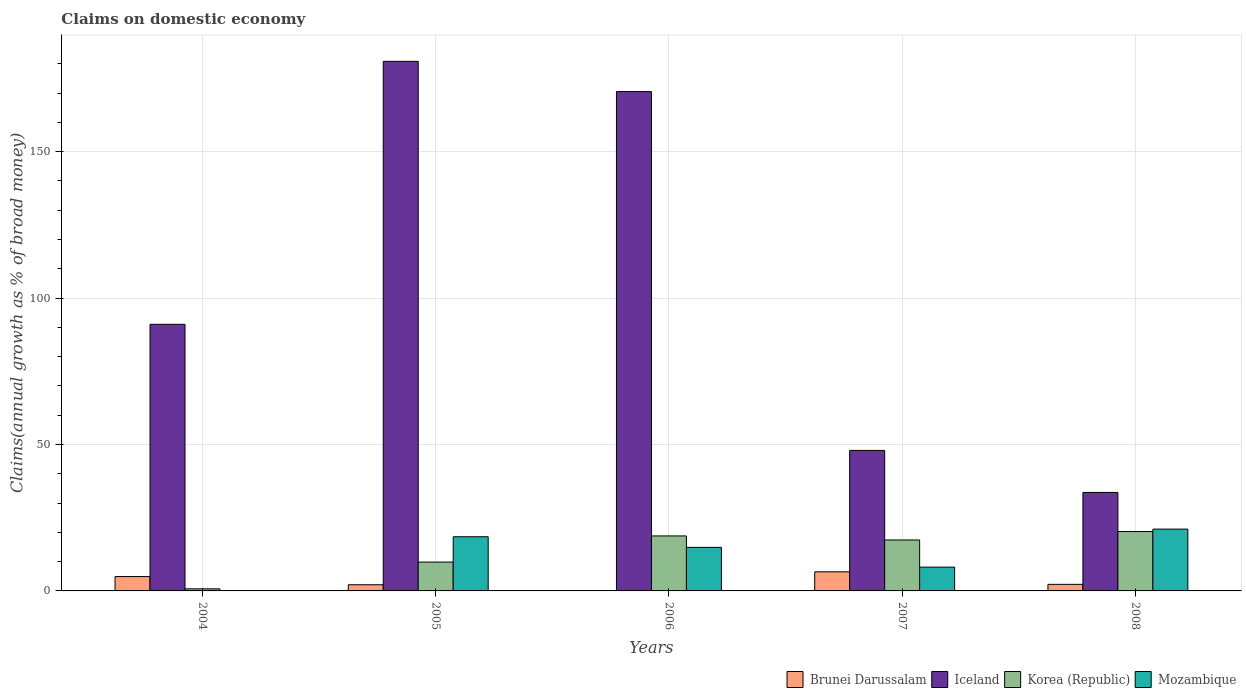How many groups of bars are there?
Your answer should be compact. 5. Are the number of bars per tick equal to the number of legend labels?
Offer a terse response. No. In how many cases, is the number of bars for a given year not equal to the number of legend labels?
Your answer should be compact. 2. What is the percentage of broad money claimed on domestic economy in Korea (Republic) in 2006?
Make the answer very short. 18.78. Across all years, what is the maximum percentage of broad money claimed on domestic economy in Mozambique?
Your answer should be very brief. 21.11. Across all years, what is the minimum percentage of broad money claimed on domestic economy in Iceland?
Keep it short and to the point. 33.63. What is the total percentage of broad money claimed on domestic economy in Korea (Republic) in the graph?
Offer a very short reply. 67.02. What is the difference between the percentage of broad money claimed on domestic economy in Korea (Republic) in 2005 and that in 2006?
Provide a short and direct response. -8.93. What is the difference between the percentage of broad money claimed on domestic economy in Mozambique in 2005 and the percentage of broad money claimed on domestic economy in Brunei Darussalam in 2006?
Keep it short and to the point. 18.5. What is the average percentage of broad money claimed on domestic economy in Korea (Republic) per year?
Make the answer very short. 13.4. In the year 2005, what is the difference between the percentage of broad money claimed on domestic economy in Korea (Republic) and percentage of broad money claimed on domestic economy in Mozambique?
Make the answer very short. -8.65. What is the ratio of the percentage of broad money claimed on domestic economy in Iceland in 2004 to that in 2007?
Provide a short and direct response. 1.9. Is the percentage of broad money claimed on domestic economy in Mozambique in 2006 less than that in 2008?
Provide a succinct answer. Yes. What is the difference between the highest and the second highest percentage of broad money claimed on domestic economy in Brunei Darussalam?
Ensure brevity in your answer.  1.62. What is the difference between the highest and the lowest percentage of broad money claimed on domestic economy in Korea (Republic)?
Keep it short and to the point. 19.55. In how many years, is the percentage of broad money claimed on domestic economy in Mozambique greater than the average percentage of broad money claimed on domestic economy in Mozambique taken over all years?
Give a very brief answer. 3. Is it the case that in every year, the sum of the percentage of broad money claimed on domestic economy in Brunei Darussalam and percentage of broad money claimed on domestic economy in Mozambique is greater than the percentage of broad money claimed on domestic economy in Iceland?
Provide a short and direct response. No. How many bars are there?
Your answer should be very brief. 18. Are all the bars in the graph horizontal?
Provide a short and direct response. No. What is the difference between two consecutive major ticks on the Y-axis?
Provide a succinct answer. 50. Are the values on the major ticks of Y-axis written in scientific E-notation?
Your answer should be compact. No. Does the graph contain grids?
Offer a very short reply. Yes. How many legend labels are there?
Offer a very short reply. 4. What is the title of the graph?
Provide a short and direct response. Claims on domestic economy. Does "Bermuda" appear as one of the legend labels in the graph?
Your answer should be compact. No. What is the label or title of the X-axis?
Keep it short and to the point. Years. What is the label or title of the Y-axis?
Provide a short and direct response. Claims(annual growth as % of broad money). What is the Claims(annual growth as % of broad money) in Brunei Darussalam in 2004?
Your answer should be compact. 4.9. What is the Claims(annual growth as % of broad money) of Iceland in 2004?
Keep it short and to the point. 91.04. What is the Claims(annual growth as % of broad money) in Korea (Republic) in 2004?
Your answer should be compact. 0.72. What is the Claims(annual growth as % of broad money) in Mozambique in 2004?
Your answer should be compact. 0. What is the Claims(annual growth as % of broad money) in Brunei Darussalam in 2005?
Ensure brevity in your answer.  2.11. What is the Claims(annual growth as % of broad money) of Iceland in 2005?
Offer a very short reply. 180.84. What is the Claims(annual growth as % of broad money) in Korea (Republic) in 2005?
Offer a very short reply. 9.85. What is the Claims(annual growth as % of broad money) of Mozambique in 2005?
Offer a very short reply. 18.5. What is the Claims(annual growth as % of broad money) in Brunei Darussalam in 2006?
Your answer should be compact. 0. What is the Claims(annual growth as % of broad money) in Iceland in 2006?
Give a very brief answer. 170.52. What is the Claims(annual growth as % of broad money) in Korea (Republic) in 2006?
Give a very brief answer. 18.78. What is the Claims(annual growth as % of broad money) of Mozambique in 2006?
Your response must be concise. 14.87. What is the Claims(annual growth as % of broad money) of Brunei Darussalam in 2007?
Provide a short and direct response. 6.52. What is the Claims(annual growth as % of broad money) of Iceland in 2007?
Offer a terse response. 47.98. What is the Claims(annual growth as % of broad money) in Korea (Republic) in 2007?
Ensure brevity in your answer.  17.4. What is the Claims(annual growth as % of broad money) in Mozambique in 2007?
Make the answer very short. 8.13. What is the Claims(annual growth as % of broad money) in Brunei Darussalam in 2008?
Give a very brief answer. 2.24. What is the Claims(annual growth as % of broad money) of Iceland in 2008?
Your answer should be compact. 33.63. What is the Claims(annual growth as % of broad money) of Korea (Republic) in 2008?
Your response must be concise. 20.27. What is the Claims(annual growth as % of broad money) in Mozambique in 2008?
Your answer should be compact. 21.11. Across all years, what is the maximum Claims(annual growth as % of broad money) in Brunei Darussalam?
Make the answer very short. 6.52. Across all years, what is the maximum Claims(annual growth as % of broad money) of Iceland?
Provide a short and direct response. 180.84. Across all years, what is the maximum Claims(annual growth as % of broad money) in Korea (Republic)?
Your answer should be compact. 20.27. Across all years, what is the maximum Claims(annual growth as % of broad money) of Mozambique?
Provide a short and direct response. 21.11. Across all years, what is the minimum Claims(annual growth as % of broad money) of Iceland?
Ensure brevity in your answer.  33.63. Across all years, what is the minimum Claims(annual growth as % of broad money) of Korea (Republic)?
Offer a terse response. 0.72. What is the total Claims(annual growth as % of broad money) of Brunei Darussalam in the graph?
Make the answer very short. 15.77. What is the total Claims(annual growth as % of broad money) of Iceland in the graph?
Keep it short and to the point. 524.01. What is the total Claims(annual growth as % of broad money) in Korea (Republic) in the graph?
Provide a short and direct response. 67.02. What is the total Claims(annual growth as % of broad money) in Mozambique in the graph?
Your answer should be very brief. 62.61. What is the difference between the Claims(annual growth as % of broad money) in Brunei Darussalam in 2004 and that in 2005?
Your answer should be compact. 2.79. What is the difference between the Claims(annual growth as % of broad money) in Iceland in 2004 and that in 2005?
Your response must be concise. -89.79. What is the difference between the Claims(annual growth as % of broad money) in Korea (Republic) in 2004 and that in 2005?
Make the answer very short. -9.13. What is the difference between the Claims(annual growth as % of broad money) in Iceland in 2004 and that in 2006?
Make the answer very short. -79.47. What is the difference between the Claims(annual growth as % of broad money) of Korea (Republic) in 2004 and that in 2006?
Your answer should be very brief. -18.06. What is the difference between the Claims(annual growth as % of broad money) of Brunei Darussalam in 2004 and that in 2007?
Make the answer very short. -1.62. What is the difference between the Claims(annual growth as % of broad money) in Iceland in 2004 and that in 2007?
Provide a short and direct response. 43.06. What is the difference between the Claims(annual growth as % of broad money) of Korea (Republic) in 2004 and that in 2007?
Make the answer very short. -16.68. What is the difference between the Claims(annual growth as % of broad money) of Brunei Darussalam in 2004 and that in 2008?
Ensure brevity in your answer.  2.66. What is the difference between the Claims(annual growth as % of broad money) in Iceland in 2004 and that in 2008?
Your answer should be very brief. 57.41. What is the difference between the Claims(annual growth as % of broad money) of Korea (Republic) in 2004 and that in 2008?
Your answer should be compact. -19.55. What is the difference between the Claims(annual growth as % of broad money) of Iceland in 2005 and that in 2006?
Your answer should be compact. 10.32. What is the difference between the Claims(annual growth as % of broad money) in Korea (Republic) in 2005 and that in 2006?
Make the answer very short. -8.93. What is the difference between the Claims(annual growth as % of broad money) of Mozambique in 2005 and that in 2006?
Your answer should be very brief. 3.62. What is the difference between the Claims(annual growth as % of broad money) of Brunei Darussalam in 2005 and that in 2007?
Offer a very short reply. -4.42. What is the difference between the Claims(annual growth as % of broad money) of Iceland in 2005 and that in 2007?
Provide a succinct answer. 132.86. What is the difference between the Claims(annual growth as % of broad money) in Korea (Republic) in 2005 and that in 2007?
Provide a succinct answer. -7.54. What is the difference between the Claims(annual growth as % of broad money) of Mozambique in 2005 and that in 2007?
Your answer should be compact. 10.37. What is the difference between the Claims(annual growth as % of broad money) of Brunei Darussalam in 2005 and that in 2008?
Ensure brevity in your answer.  -0.14. What is the difference between the Claims(annual growth as % of broad money) of Iceland in 2005 and that in 2008?
Your answer should be very brief. 147.21. What is the difference between the Claims(annual growth as % of broad money) of Korea (Republic) in 2005 and that in 2008?
Provide a short and direct response. -10.42. What is the difference between the Claims(annual growth as % of broad money) in Mozambique in 2005 and that in 2008?
Your answer should be very brief. -2.61. What is the difference between the Claims(annual growth as % of broad money) of Iceland in 2006 and that in 2007?
Keep it short and to the point. 122.54. What is the difference between the Claims(annual growth as % of broad money) in Korea (Republic) in 2006 and that in 2007?
Ensure brevity in your answer.  1.38. What is the difference between the Claims(annual growth as % of broad money) of Mozambique in 2006 and that in 2007?
Provide a short and direct response. 6.75. What is the difference between the Claims(annual growth as % of broad money) in Iceland in 2006 and that in 2008?
Ensure brevity in your answer.  136.89. What is the difference between the Claims(annual growth as % of broad money) of Korea (Republic) in 2006 and that in 2008?
Your response must be concise. -1.49. What is the difference between the Claims(annual growth as % of broad money) of Mozambique in 2006 and that in 2008?
Offer a terse response. -6.24. What is the difference between the Claims(annual growth as % of broad money) of Brunei Darussalam in 2007 and that in 2008?
Provide a succinct answer. 4.28. What is the difference between the Claims(annual growth as % of broad money) of Iceland in 2007 and that in 2008?
Your answer should be very brief. 14.35. What is the difference between the Claims(annual growth as % of broad money) of Korea (Republic) in 2007 and that in 2008?
Your answer should be compact. -2.88. What is the difference between the Claims(annual growth as % of broad money) of Mozambique in 2007 and that in 2008?
Keep it short and to the point. -12.99. What is the difference between the Claims(annual growth as % of broad money) in Brunei Darussalam in 2004 and the Claims(annual growth as % of broad money) in Iceland in 2005?
Offer a very short reply. -175.94. What is the difference between the Claims(annual growth as % of broad money) in Brunei Darussalam in 2004 and the Claims(annual growth as % of broad money) in Korea (Republic) in 2005?
Give a very brief answer. -4.95. What is the difference between the Claims(annual growth as % of broad money) in Brunei Darussalam in 2004 and the Claims(annual growth as % of broad money) in Mozambique in 2005?
Provide a short and direct response. -13.6. What is the difference between the Claims(annual growth as % of broad money) of Iceland in 2004 and the Claims(annual growth as % of broad money) of Korea (Republic) in 2005?
Offer a very short reply. 81.19. What is the difference between the Claims(annual growth as % of broad money) of Iceland in 2004 and the Claims(annual growth as % of broad money) of Mozambique in 2005?
Your answer should be very brief. 72.55. What is the difference between the Claims(annual growth as % of broad money) of Korea (Republic) in 2004 and the Claims(annual growth as % of broad money) of Mozambique in 2005?
Your answer should be compact. -17.78. What is the difference between the Claims(annual growth as % of broad money) of Brunei Darussalam in 2004 and the Claims(annual growth as % of broad money) of Iceland in 2006?
Keep it short and to the point. -165.62. What is the difference between the Claims(annual growth as % of broad money) in Brunei Darussalam in 2004 and the Claims(annual growth as % of broad money) in Korea (Republic) in 2006?
Offer a very short reply. -13.88. What is the difference between the Claims(annual growth as % of broad money) in Brunei Darussalam in 2004 and the Claims(annual growth as % of broad money) in Mozambique in 2006?
Give a very brief answer. -9.97. What is the difference between the Claims(annual growth as % of broad money) in Iceland in 2004 and the Claims(annual growth as % of broad money) in Korea (Republic) in 2006?
Give a very brief answer. 72.27. What is the difference between the Claims(annual growth as % of broad money) in Iceland in 2004 and the Claims(annual growth as % of broad money) in Mozambique in 2006?
Make the answer very short. 76.17. What is the difference between the Claims(annual growth as % of broad money) of Korea (Republic) in 2004 and the Claims(annual growth as % of broad money) of Mozambique in 2006?
Your answer should be very brief. -14.16. What is the difference between the Claims(annual growth as % of broad money) in Brunei Darussalam in 2004 and the Claims(annual growth as % of broad money) in Iceland in 2007?
Your answer should be very brief. -43.08. What is the difference between the Claims(annual growth as % of broad money) in Brunei Darussalam in 2004 and the Claims(annual growth as % of broad money) in Korea (Republic) in 2007?
Offer a very short reply. -12.5. What is the difference between the Claims(annual growth as % of broad money) in Brunei Darussalam in 2004 and the Claims(annual growth as % of broad money) in Mozambique in 2007?
Provide a succinct answer. -3.23. What is the difference between the Claims(annual growth as % of broad money) in Iceland in 2004 and the Claims(annual growth as % of broad money) in Korea (Republic) in 2007?
Ensure brevity in your answer.  73.65. What is the difference between the Claims(annual growth as % of broad money) in Iceland in 2004 and the Claims(annual growth as % of broad money) in Mozambique in 2007?
Provide a succinct answer. 82.92. What is the difference between the Claims(annual growth as % of broad money) in Korea (Republic) in 2004 and the Claims(annual growth as % of broad money) in Mozambique in 2007?
Your answer should be very brief. -7.41. What is the difference between the Claims(annual growth as % of broad money) in Brunei Darussalam in 2004 and the Claims(annual growth as % of broad money) in Iceland in 2008?
Provide a succinct answer. -28.73. What is the difference between the Claims(annual growth as % of broad money) in Brunei Darussalam in 2004 and the Claims(annual growth as % of broad money) in Korea (Republic) in 2008?
Offer a terse response. -15.37. What is the difference between the Claims(annual growth as % of broad money) in Brunei Darussalam in 2004 and the Claims(annual growth as % of broad money) in Mozambique in 2008?
Offer a terse response. -16.21. What is the difference between the Claims(annual growth as % of broad money) of Iceland in 2004 and the Claims(annual growth as % of broad money) of Korea (Republic) in 2008?
Your response must be concise. 70.77. What is the difference between the Claims(annual growth as % of broad money) of Iceland in 2004 and the Claims(annual growth as % of broad money) of Mozambique in 2008?
Provide a short and direct response. 69.93. What is the difference between the Claims(annual growth as % of broad money) of Korea (Republic) in 2004 and the Claims(annual growth as % of broad money) of Mozambique in 2008?
Make the answer very short. -20.39. What is the difference between the Claims(annual growth as % of broad money) in Brunei Darussalam in 2005 and the Claims(annual growth as % of broad money) in Iceland in 2006?
Offer a terse response. -168.41. What is the difference between the Claims(annual growth as % of broad money) in Brunei Darussalam in 2005 and the Claims(annual growth as % of broad money) in Korea (Republic) in 2006?
Keep it short and to the point. -16.67. What is the difference between the Claims(annual growth as % of broad money) in Brunei Darussalam in 2005 and the Claims(annual growth as % of broad money) in Mozambique in 2006?
Give a very brief answer. -12.77. What is the difference between the Claims(annual growth as % of broad money) of Iceland in 2005 and the Claims(annual growth as % of broad money) of Korea (Republic) in 2006?
Offer a terse response. 162.06. What is the difference between the Claims(annual growth as % of broad money) in Iceland in 2005 and the Claims(annual growth as % of broad money) in Mozambique in 2006?
Offer a terse response. 165.96. What is the difference between the Claims(annual growth as % of broad money) of Korea (Republic) in 2005 and the Claims(annual growth as % of broad money) of Mozambique in 2006?
Provide a short and direct response. -5.02. What is the difference between the Claims(annual growth as % of broad money) of Brunei Darussalam in 2005 and the Claims(annual growth as % of broad money) of Iceland in 2007?
Your answer should be very brief. -45.87. What is the difference between the Claims(annual growth as % of broad money) of Brunei Darussalam in 2005 and the Claims(annual growth as % of broad money) of Korea (Republic) in 2007?
Your answer should be compact. -15.29. What is the difference between the Claims(annual growth as % of broad money) of Brunei Darussalam in 2005 and the Claims(annual growth as % of broad money) of Mozambique in 2007?
Offer a terse response. -6.02. What is the difference between the Claims(annual growth as % of broad money) in Iceland in 2005 and the Claims(annual growth as % of broad money) in Korea (Republic) in 2007?
Offer a very short reply. 163.44. What is the difference between the Claims(annual growth as % of broad money) in Iceland in 2005 and the Claims(annual growth as % of broad money) in Mozambique in 2007?
Give a very brief answer. 172.71. What is the difference between the Claims(annual growth as % of broad money) in Korea (Republic) in 2005 and the Claims(annual growth as % of broad money) in Mozambique in 2007?
Offer a very short reply. 1.72. What is the difference between the Claims(annual growth as % of broad money) in Brunei Darussalam in 2005 and the Claims(annual growth as % of broad money) in Iceland in 2008?
Keep it short and to the point. -31.53. What is the difference between the Claims(annual growth as % of broad money) in Brunei Darussalam in 2005 and the Claims(annual growth as % of broad money) in Korea (Republic) in 2008?
Your answer should be compact. -18.17. What is the difference between the Claims(annual growth as % of broad money) of Brunei Darussalam in 2005 and the Claims(annual growth as % of broad money) of Mozambique in 2008?
Give a very brief answer. -19. What is the difference between the Claims(annual growth as % of broad money) of Iceland in 2005 and the Claims(annual growth as % of broad money) of Korea (Republic) in 2008?
Provide a succinct answer. 160.57. What is the difference between the Claims(annual growth as % of broad money) in Iceland in 2005 and the Claims(annual growth as % of broad money) in Mozambique in 2008?
Your answer should be very brief. 159.73. What is the difference between the Claims(annual growth as % of broad money) in Korea (Republic) in 2005 and the Claims(annual growth as % of broad money) in Mozambique in 2008?
Provide a succinct answer. -11.26. What is the difference between the Claims(annual growth as % of broad money) in Iceland in 2006 and the Claims(annual growth as % of broad money) in Korea (Republic) in 2007?
Your answer should be compact. 153.12. What is the difference between the Claims(annual growth as % of broad money) of Iceland in 2006 and the Claims(annual growth as % of broad money) of Mozambique in 2007?
Provide a short and direct response. 162.39. What is the difference between the Claims(annual growth as % of broad money) of Korea (Republic) in 2006 and the Claims(annual growth as % of broad money) of Mozambique in 2007?
Give a very brief answer. 10.65. What is the difference between the Claims(annual growth as % of broad money) of Iceland in 2006 and the Claims(annual growth as % of broad money) of Korea (Republic) in 2008?
Provide a succinct answer. 150.25. What is the difference between the Claims(annual growth as % of broad money) in Iceland in 2006 and the Claims(annual growth as % of broad money) in Mozambique in 2008?
Offer a very short reply. 149.41. What is the difference between the Claims(annual growth as % of broad money) of Korea (Republic) in 2006 and the Claims(annual growth as % of broad money) of Mozambique in 2008?
Your answer should be very brief. -2.33. What is the difference between the Claims(annual growth as % of broad money) in Brunei Darussalam in 2007 and the Claims(annual growth as % of broad money) in Iceland in 2008?
Provide a succinct answer. -27.11. What is the difference between the Claims(annual growth as % of broad money) in Brunei Darussalam in 2007 and the Claims(annual growth as % of broad money) in Korea (Republic) in 2008?
Your answer should be compact. -13.75. What is the difference between the Claims(annual growth as % of broad money) of Brunei Darussalam in 2007 and the Claims(annual growth as % of broad money) of Mozambique in 2008?
Your answer should be compact. -14.59. What is the difference between the Claims(annual growth as % of broad money) of Iceland in 2007 and the Claims(annual growth as % of broad money) of Korea (Republic) in 2008?
Your response must be concise. 27.71. What is the difference between the Claims(annual growth as % of broad money) of Iceland in 2007 and the Claims(annual growth as % of broad money) of Mozambique in 2008?
Keep it short and to the point. 26.87. What is the difference between the Claims(annual growth as % of broad money) in Korea (Republic) in 2007 and the Claims(annual growth as % of broad money) in Mozambique in 2008?
Provide a succinct answer. -3.72. What is the average Claims(annual growth as % of broad money) of Brunei Darussalam per year?
Make the answer very short. 3.15. What is the average Claims(annual growth as % of broad money) in Iceland per year?
Offer a very short reply. 104.8. What is the average Claims(annual growth as % of broad money) in Korea (Republic) per year?
Ensure brevity in your answer.  13.4. What is the average Claims(annual growth as % of broad money) of Mozambique per year?
Provide a succinct answer. 12.52. In the year 2004, what is the difference between the Claims(annual growth as % of broad money) in Brunei Darussalam and Claims(annual growth as % of broad money) in Iceland?
Make the answer very short. -86.15. In the year 2004, what is the difference between the Claims(annual growth as % of broad money) in Brunei Darussalam and Claims(annual growth as % of broad money) in Korea (Republic)?
Your answer should be very brief. 4.18. In the year 2004, what is the difference between the Claims(annual growth as % of broad money) of Iceland and Claims(annual growth as % of broad money) of Korea (Republic)?
Your answer should be very brief. 90.33. In the year 2005, what is the difference between the Claims(annual growth as % of broad money) in Brunei Darussalam and Claims(annual growth as % of broad money) in Iceland?
Give a very brief answer. -178.73. In the year 2005, what is the difference between the Claims(annual growth as % of broad money) of Brunei Darussalam and Claims(annual growth as % of broad money) of Korea (Republic)?
Your response must be concise. -7.74. In the year 2005, what is the difference between the Claims(annual growth as % of broad money) of Brunei Darussalam and Claims(annual growth as % of broad money) of Mozambique?
Provide a succinct answer. -16.39. In the year 2005, what is the difference between the Claims(annual growth as % of broad money) of Iceland and Claims(annual growth as % of broad money) of Korea (Republic)?
Your answer should be compact. 170.99. In the year 2005, what is the difference between the Claims(annual growth as % of broad money) in Iceland and Claims(annual growth as % of broad money) in Mozambique?
Ensure brevity in your answer.  162.34. In the year 2005, what is the difference between the Claims(annual growth as % of broad money) of Korea (Republic) and Claims(annual growth as % of broad money) of Mozambique?
Make the answer very short. -8.65. In the year 2006, what is the difference between the Claims(annual growth as % of broad money) of Iceland and Claims(annual growth as % of broad money) of Korea (Republic)?
Provide a succinct answer. 151.74. In the year 2006, what is the difference between the Claims(annual growth as % of broad money) in Iceland and Claims(annual growth as % of broad money) in Mozambique?
Provide a succinct answer. 155.64. In the year 2006, what is the difference between the Claims(annual growth as % of broad money) in Korea (Republic) and Claims(annual growth as % of broad money) in Mozambique?
Make the answer very short. 3.91. In the year 2007, what is the difference between the Claims(annual growth as % of broad money) in Brunei Darussalam and Claims(annual growth as % of broad money) in Iceland?
Keep it short and to the point. -41.46. In the year 2007, what is the difference between the Claims(annual growth as % of broad money) of Brunei Darussalam and Claims(annual growth as % of broad money) of Korea (Republic)?
Offer a very short reply. -10.87. In the year 2007, what is the difference between the Claims(annual growth as % of broad money) of Brunei Darussalam and Claims(annual growth as % of broad money) of Mozambique?
Offer a terse response. -1.6. In the year 2007, what is the difference between the Claims(annual growth as % of broad money) in Iceland and Claims(annual growth as % of broad money) in Korea (Republic)?
Provide a short and direct response. 30.58. In the year 2007, what is the difference between the Claims(annual growth as % of broad money) in Iceland and Claims(annual growth as % of broad money) in Mozambique?
Offer a very short reply. 39.85. In the year 2007, what is the difference between the Claims(annual growth as % of broad money) of Korea (Republic) and Claims(annual growth as % of broad money) of Mozambique?
Ensure brevity in your answer.  9.27. In the year 2008, what is the difference between the Claims(annual growth as % of broad money) of Brunei Darussalam and Claims(annual growth as % of broad money) of Iceland?
Ensure brevity in your answer.  -31.39. In the year 2008, what is the difference between the Claims(annual growth as % of broad money) of Brunei Darussalam and Claims(annual growth as % of broad money) of Korea (Republic)?
Your answer should be very brief. -18.03. In the year 2008, what is the difference between the Claims(annual growth as % of broad money) in Brunei Darussalam and Claims(annual growth as % of broad money) in Mozambique?
Offer a very short reply. -18.87. In the year 2008, what is the difference between the Claims(annual growth as % of broad money) of Iceland and Claims(annual growth as % of broad money) of Korea (Republic)?
Your answer should be compact. 13.36. In the year 2008, what is the difference between the Claims(annual growth as % of broad money) in Iceland and Claims(annual growth as % of broad money) in Mozambique?
Provide a succinct answer. 12.52. In the year 2008, what is the difference between the Claims(annual growth as % of broad money) in Korea (Republic) and Claims(annual growth as % of broad money) in Mozambique?
Provide a short and direct response. -0.84. What is the ratio of the Claims(annual growth as % of broad money) in Brunei Darussalam in 2004 to that in 2005?
Your response must be concise. 2.33. What is the ratio of the Claims(annual growth as % of broad money) of Iceland in 2004 to that in 2005?
Make the answer very short. 0.5. What is the ratio of the Claims(annual growth as % of broad money) of Korea (Republic) in 2004 to that in 2005?
Offer a terse response. 0.07. What is the ratio of the Claims(annual growth as % of broad money) in Iceland in 2004 to that in 2006?
Keep it short and to the point. 0.53. What is the ratio of the Claims(annual growth as % of broad money) of Korea (Republic) in 2004 to that in 2006?
Your response must be concise. 0.04. What is the ratio of the Claims(annual growth as % of broad money) of Brunei Darussalam in 2004 to that in 2007?
Make the answer very short. 0.75. What is the ratio of the Claims(annual growth as % of broad money) of Iceland in 2004 to that in 2007?
Your answer should be compact. 1.9. What is the ratio of the Claims(annual growth as % of broad money) of Korea (Republic) in 2004 to that in 2007?
Offer a terse response. 0.04. What is the ratio of the Claims(annual growth as % of broad money) in Brunei Darussalam in 2004 to that in 2008?
Provide a short and direct response. 2.18. What is the ratio of the Claims(annual growth as % of broad money) in Iceland in 2004 to that in 2008?
Give a very brief answer. 2.71. What is the ratio of the Claims(annual growth as % of broad money) of Korea (Republic) in 2004 to that in 2008?
Your response must be concise. 0.04. What is the ratio of the Claims(annual growth as % of broad money) of Iceland in 2005 to that in 2006?
Your response must be concise. 1.06. What is the ratio of the Claims(annual growth as % of broad money) of Korea (Republic) in 2005 to that in 2006?
Give a very brief answer. 0.52. What is the ratio of the Claims(annual growth as % of broad money) in Mozambique in 2005 to that in 2006?
Keep it short and to the point. 1.24. What is the ratio of the Claims(annual growth as % of broad money) in Brunei Darussalam in 2005 to that in 2007?
Ensure brevity in your answer.  0.32. What is the ratio of the Claims(annual growth as % of broad money) of Iceland in 2005 to that in 2007?
Your response must be concise. 3.77. What is the ratio of the Claims(annual growth as % of broad money) in Korea (Republic) in 2005 to that in 2007?
Offer a very short reply. 0.57. What is the ratio of the Claims(annual growth as % of broad money) of Mozambique in 2005 to that in 2007?
Make the answer very short. 2.28. What is the ratio of the Claims(annual growth as % of broad money) in Brunei Darussalam in 2005 to that in 2008?
Make the answer very short. 0.94. What is the ratio of the Claims(annual growth as % of broad money) of Iceland in 2005 to that in 2008?
Ensure brevity in your answer.  5.38. What is the ratio of the Claims(annual growth as % of broad money) in Korea (Republic) in 2005 to that in 2008?
Offer a very short reply. 0.49. What is the ratio of the Claims(annual growth as % of broad money) of Mozambique in 2005 to that in 2008?
Provide a succinct answer. 0.88. What is the ratio of the Claims(annual growth as % of broad money) in Iceland in 2006 to that in 2007?
Your response must be concise. 3.55. What is the ratio of the Claims(annual growth as % of broad money) of Korea (Republic) in 2006 to that in 2007?
Your answer should be compact. 1.08. What is the ratio of the Claims(annual growth as % of broad money) of Mozambique in 2006 to that in 2007?
Offer a terse response. 1.83. What is the ratio of the Claims(annual growth as % of broad money) of Iceland in 2006 to that in 2008?
Make the answer very short. 5.07. What is the ratio of the Claims(annual growth as % of broad money) of Korea (Republic) in 2006 to that in 2008?
Your response must be concise. 0.93. What is the ratio of the Claims(annual growth as % of broad money) in Mozambique in 2006 to that in 2008?
Offer a terse response. 0.7. What is the ratio of the Claims(annual growth as % of broad money) of Brunei Darussalam in 2007 to that in 2008?
Give a very brief answer. 2.91. What is the ratio of the Claims(annual growth as % of broad money) in Iceland in 2007 to that in 2008?
Provide a succinct answer. 1.43. What is the ratio of the Claims(annual growth as % of broad money) in Korea (Republic) in 2007 to that in 2008?
Your answer should be very brief. 0.86. What is the ratio of the Claims(annual growth as % of broad money) of Mozambique in 2007 to that in 2008?
Keep it short and to the point. 0.38. What is the difference between the highest and the second highest Claims(annual growth as % of broad money) in Brunei Darussalam?
Ensure brevity in your answer.  1.62. What is the difference between the highest and the second highest Claims(annual growth as % of broad money) of Iceland?
Provide a short and direct response. 10.32. What is the difference between the highest and the second highest Claims(annual growth as % of broad money) of Korea (Republic)?
Keep it short and to the point. 1.49. What is the difference between the highest and the second highest Claims(annual growth as % of broad money) in Mozambique?
Give a very brief answer. 2.61. What is the difference between the highest and the lowest Claims(annual growth as % of broad money) of Brunei Darussalam?
Your answer should be very brief. 6.52. What is the difference between the highest and the lowest Claims(annual growth as % of broad money) of Iceland?
Your answer should be compact. 147.21. What is the difference between the highest and the lowest Claims(annual growth as % of broad money) of Korea (Republic)?
Offer a terse response. 19.55. What is the difference between the highest and the lowest Claims(annual growth as % of broad money) in Mozambique?
Your answer should be very brief. 21.11. 